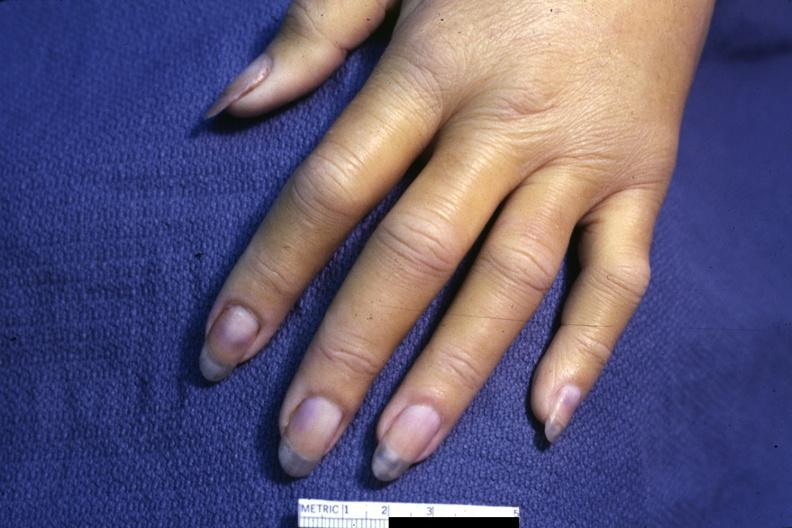s acrocyanosis present?
Answer the question using a single word or phrase. Yes 